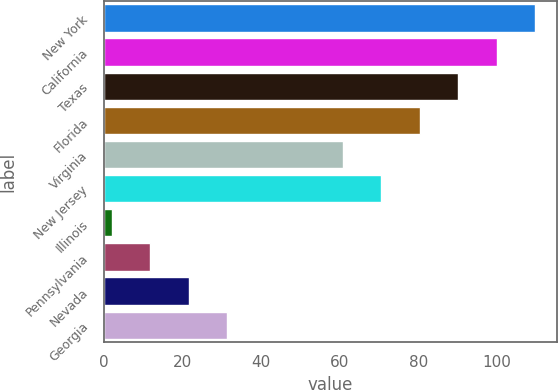Convert chart to OTSL. <chart><loc_0><loc_0><loc_500><loc_500><bar_chart><fcel>New York<fcel>California<fcel>Texas<fcel>Florida<fcel>Virginia<fcel>New Jersey<fcel>Illinois<fcel>Pennsylvania<fcel>Nevada<fcel>Georgia<nl><fcel>109.8<fcel>100<fcel>90.2<fcel>80.4<fcel>60.8<fcel>70.6<fcel>2<fcel>11.8<fcel>21.6<fcel>31.4<nl></chart> 